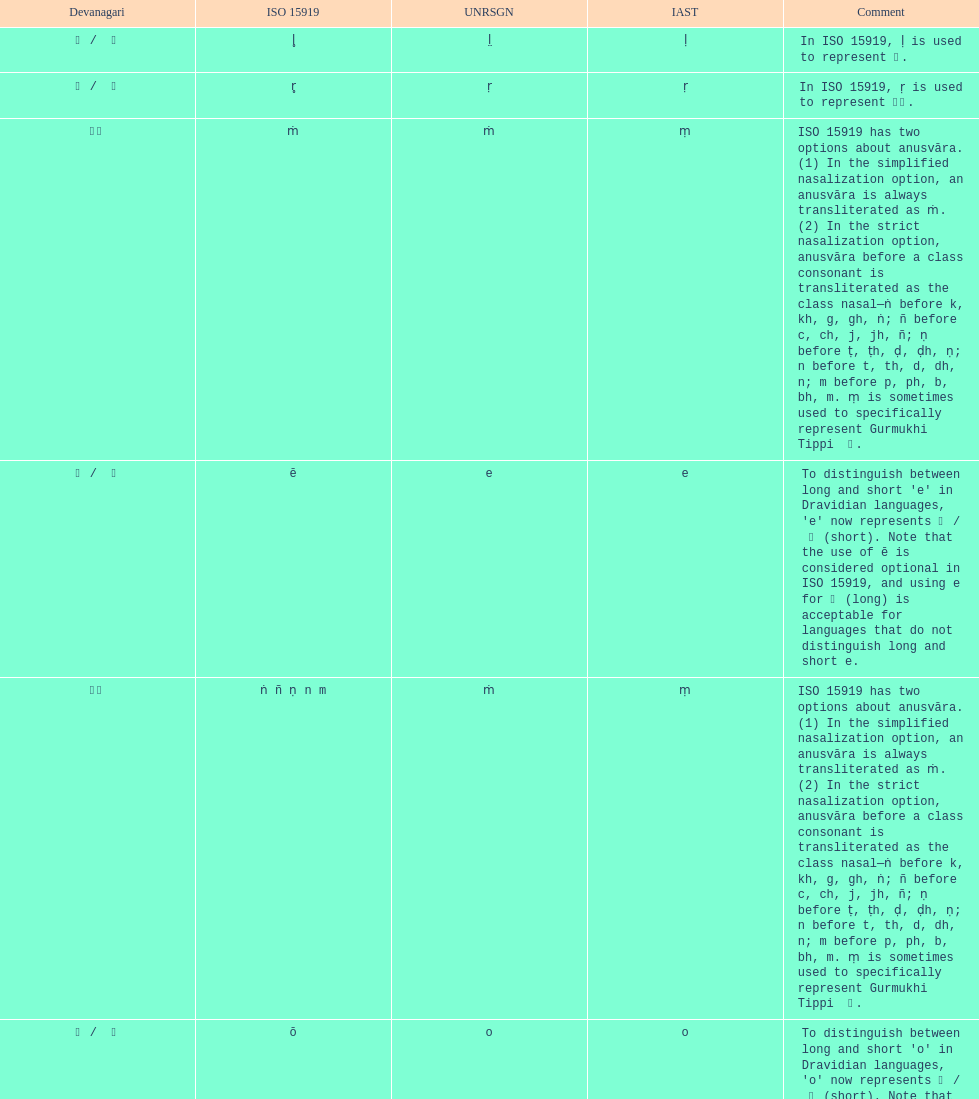What unrsgn is listed previous to the o? E. 